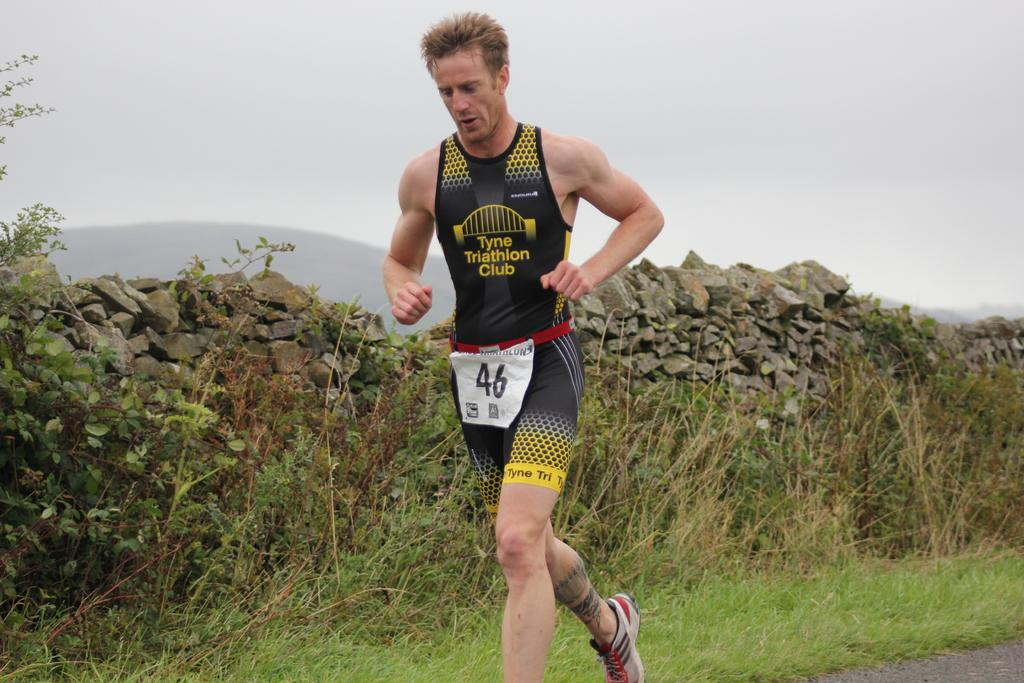Provide a one-sentence caption for the provided image. A runner from the Tyne Triathlon Club is identified as number 46. 46. 